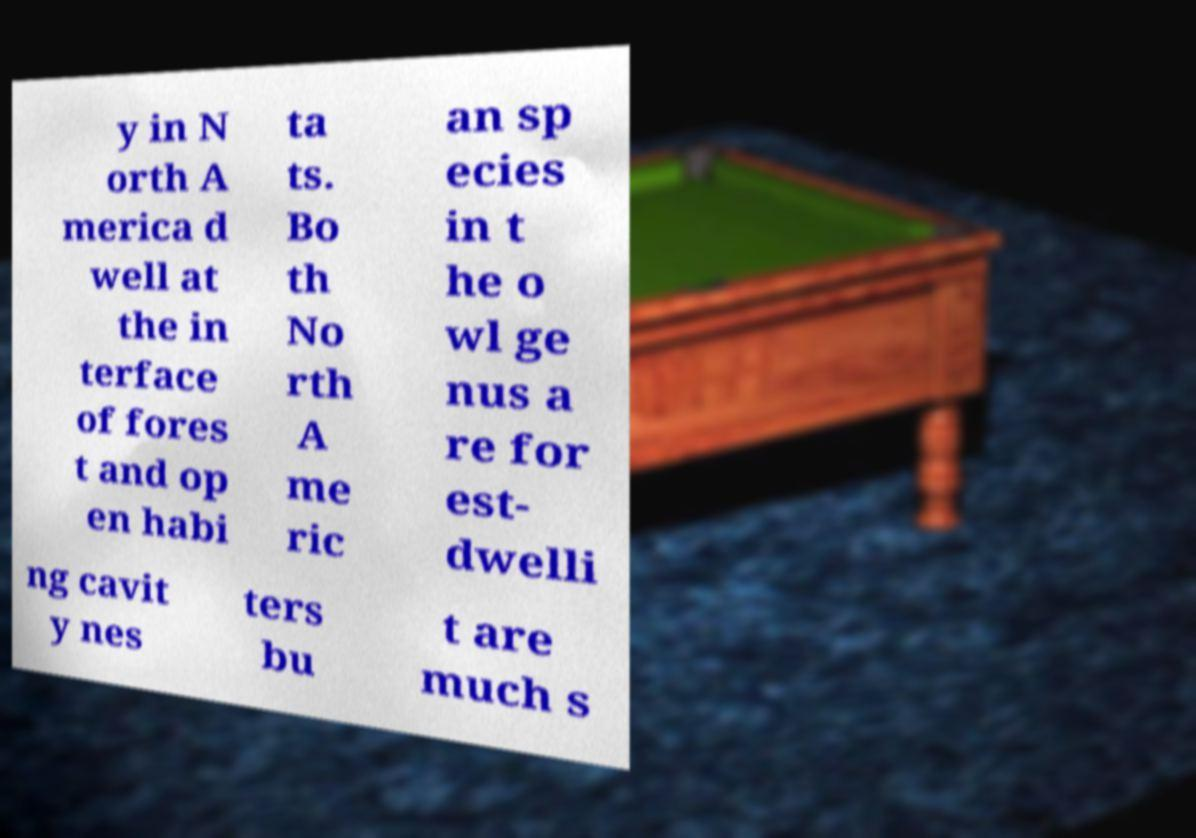Please identify and transcribe the text found in this image. y in N orth A merica d well at the in terface of fores t and op en habi ta ts. Bo th No rth A me ric an sp ecies in t he o wl ge nus a re for est- dwelli ng cavit y nes ters bu t are much s 